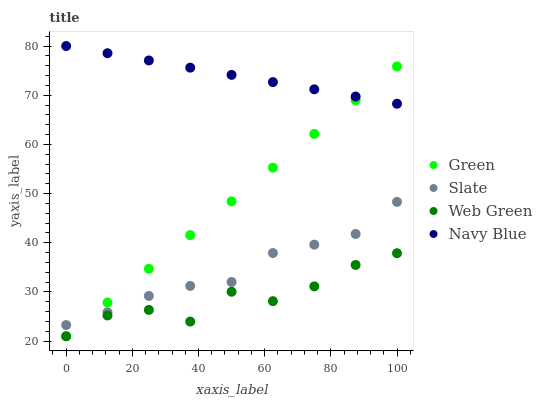Does Web Green have the minimum area under the curve?
Answer yes or no. Yes. Does Navy Blue have the maximum area under the curve?
Answer yes or no. Yes. Does Slate have the minimum area under the curve?
Answer yes or no. No. Does Slate have the maximum area under the curve?
Answer yes or no. No. Is Green the smoothest?
Answer yes or no. Yes. Is Web Green the roughest?
Answer yes or no. Yes. Is Slate the smoothest?
Answer yes or no. No. Is Slate the roughest?
Answer yes or no. No. Does Green have the lowest value?
Answer yes or no. Yes. Does Slate have the lowest value?
Answer yes or no. No. Does Navy Blue have the highest value?
Answer yes or no. Yes. Does Slate have the highest value?
Answer yes or no. No. Is Slate less than Navy Blue?
Answer yes or no. Yes. Is Slate greater than Web Green?
Answer yes or no. Yes. Does Slate intersect Green?
Answer yes or no. Yes. Is Slate less than Green?
Answer yes or no. No. Is Slate greater than Green?
Answer yes or no. No. Does Slate intersect Navy Blue?
Answer yes or no. No. 